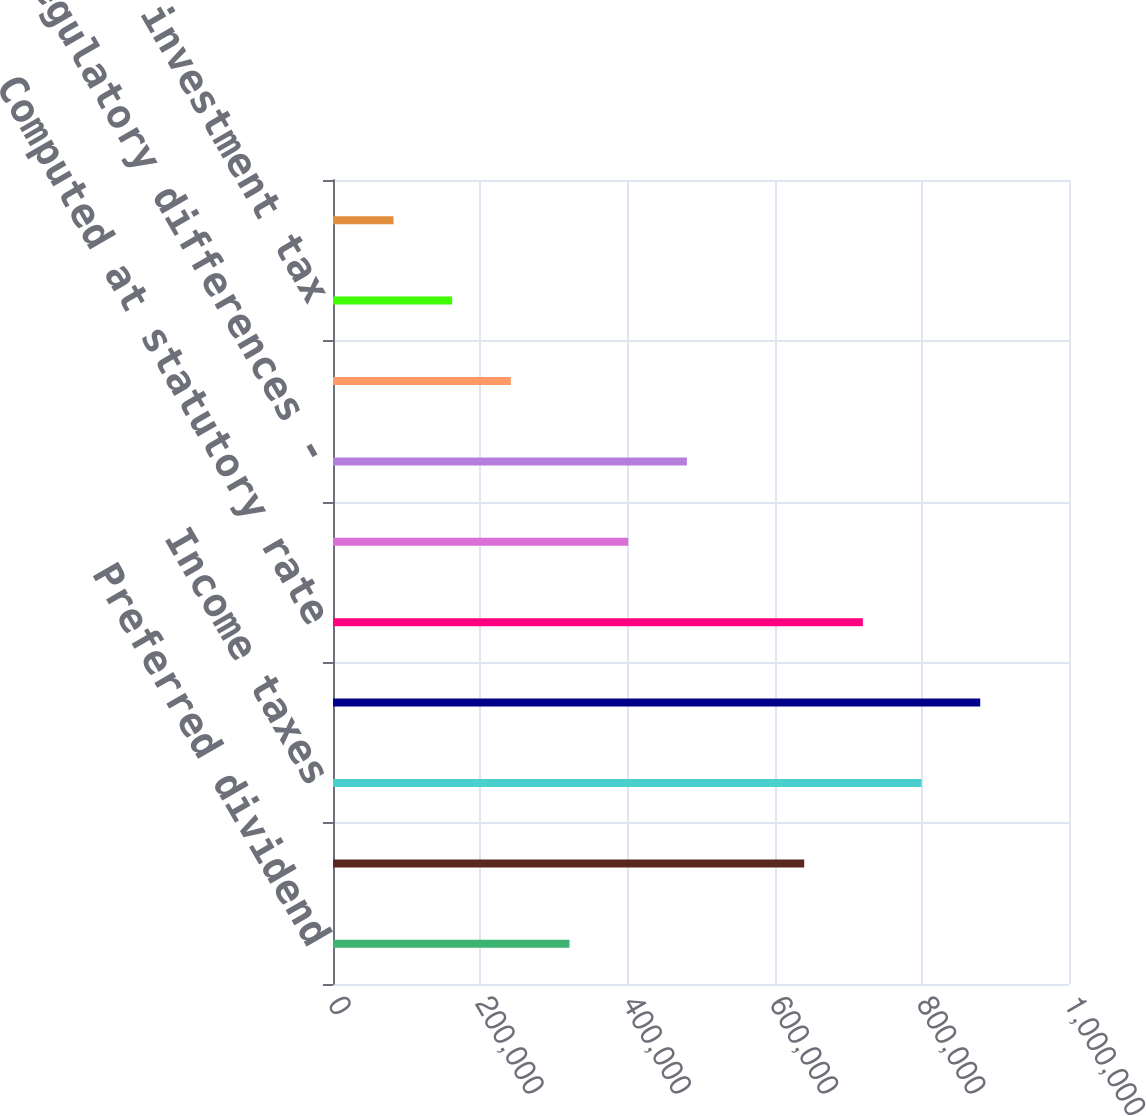Convert chart. <chart><loc_0><loc_0><loc_500><loc_500><bar_chart><fcel>Preferred dividend<fcel>Consolidated net income (loss)<fcel>Income taxes<fcel>Income (loss) before income<fcel>Computed at statutory rate<fcel>State income taxes net of<fcel>Regulatory differences -<fcel>Equity component of AFUDC<fcel>Amortization of investment tax<fcel>Flow-through / permanent<nl><fcel>321339<fcel>640220<fcel>799661<fcel>879381<fcel>719941<fcel>401060<fcel>480780<fcel>241619<fcel>161899<fcel>82178.3<nl></chart> 